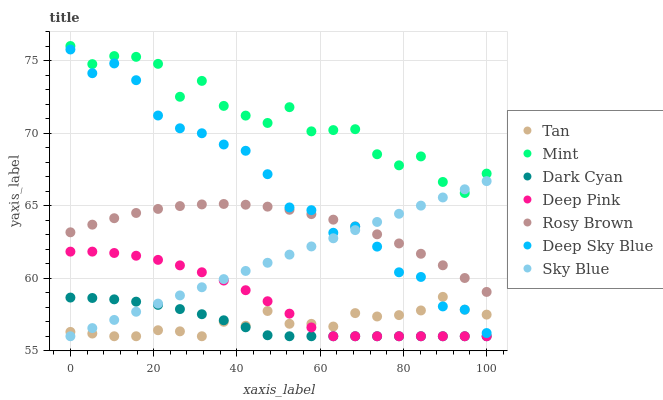Does Dark Cyan have the minimum area under the curve?
Answer yes or no. Yes. Does Mint have the maximum area under the curve?
Answer yes or no. Yes. Does Rosy Brown have the minimum area under the curve?
Answer yes or no. No. Does Rosy Brown have the maximum area under the curve?
Answer yes or no. No. Is Sky Blue the smoothest?
Answer yes or no. Yes. Is Mint the roughest?
Answer yes or no. Yes. Is Rosy Brown the smoothest?
Answer yes or no. No. Is Rosy Brown the roughest?
Answer yes or no. No. Does Deep Pink have the lowest value?
Answer yes or no. Yes. Does Rosy Brown have the lowest value?
Answer yes or no. No. Does Mint have the highest value?
Answer yes or no. Yes. Does Rosy Brown have the highest value?
Answer yes or no. No. Is Dark Cyan less than Mint?
Answer yes or no. Yes. Is Rosy Brown greater than Dark Cyan?
Answer yes or no. Yes. Does Dark Cyan intersect Deep Pink?
Answer yes or no. Yes. Is Dark Cyan less than Deep Pink?
Answer yes or no. No. Is Dark Cyan greater than Deep Pink?
Answer yes or no. No. Does Dark Cyan intersect Mint?
Answer yes or no. No. 